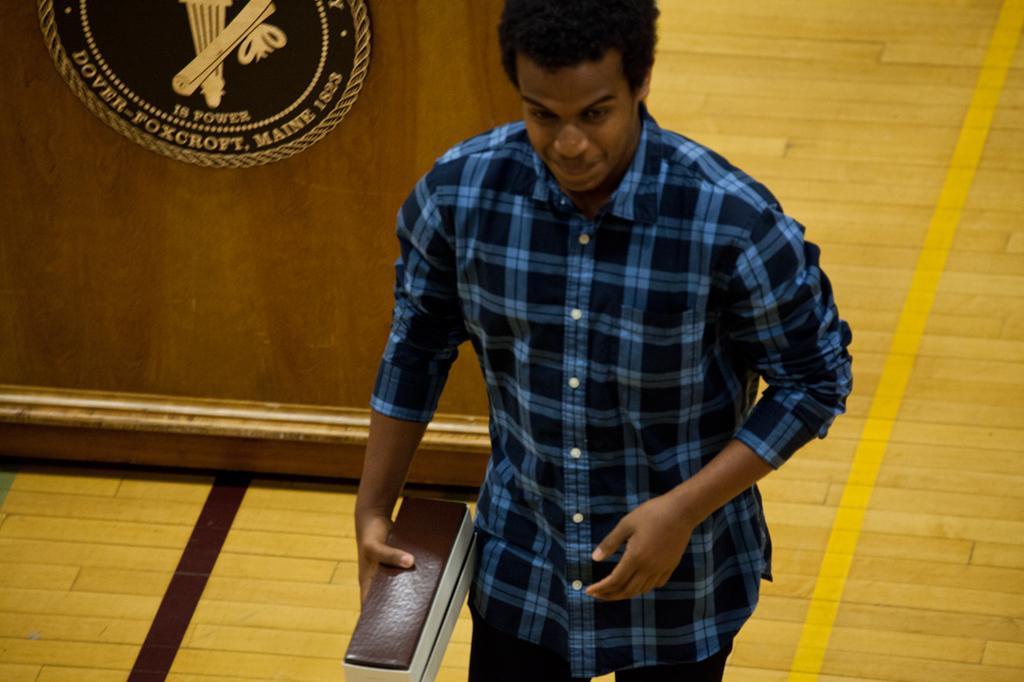How would you summarize this image in a sentence or two? In the center of the image there is a person holding an holding an object. In the background we can see a podium and also floor. 